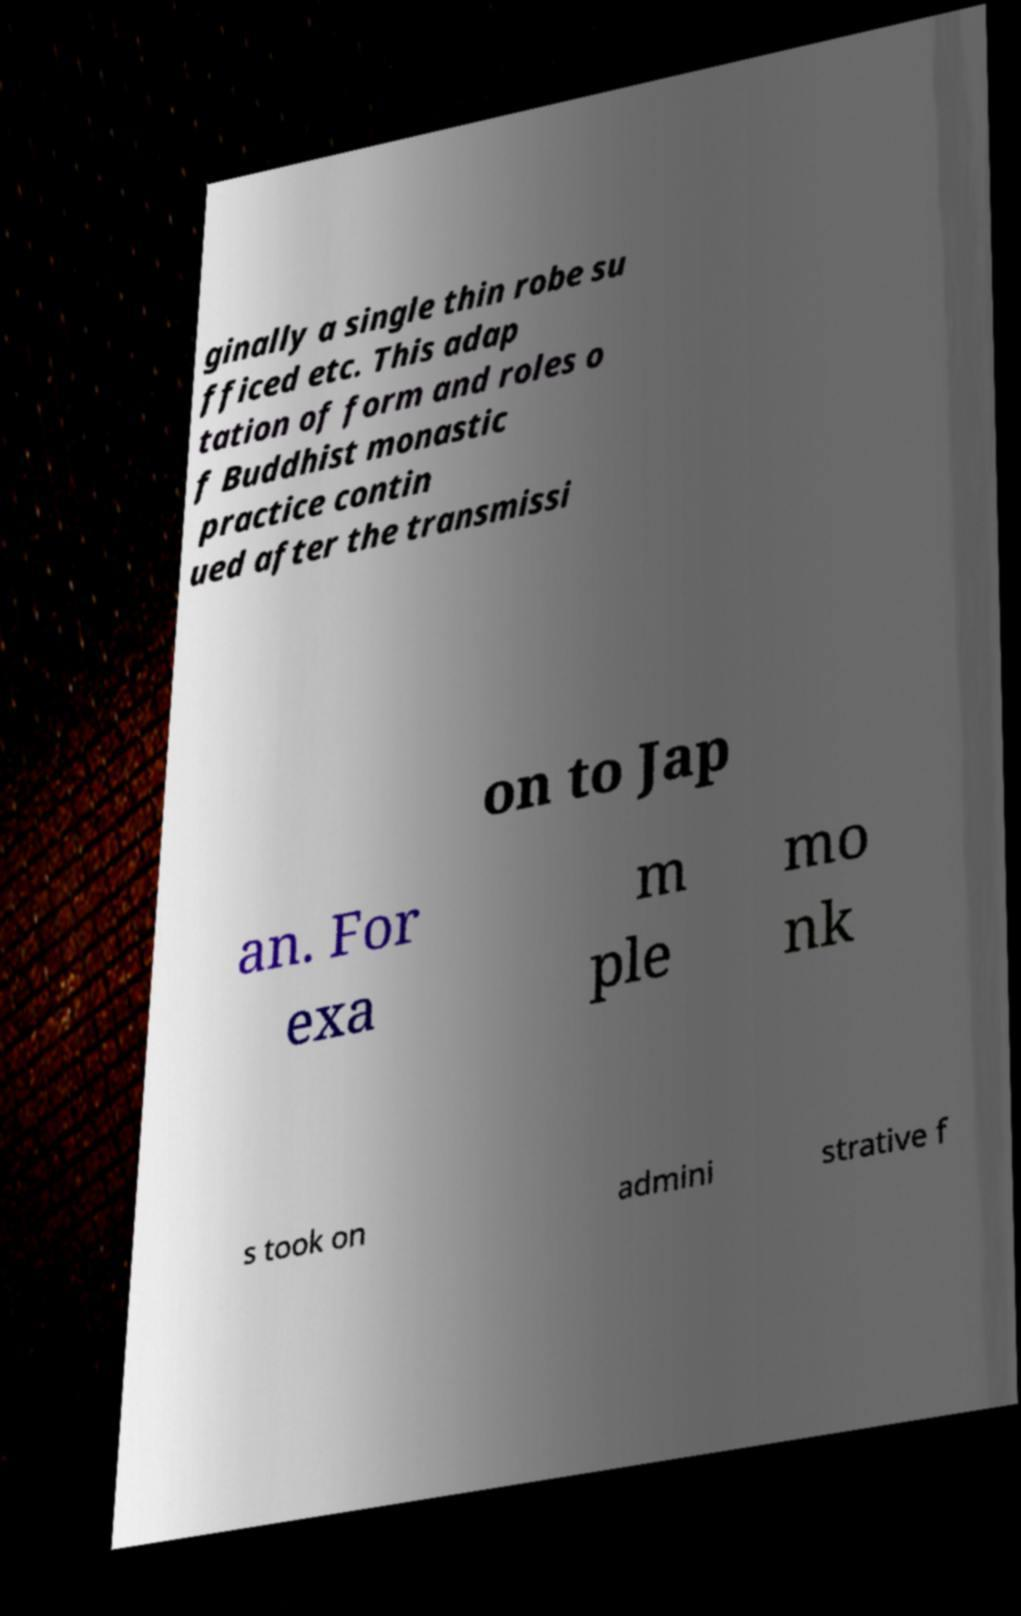I need the written content from this picture converted into text. Can you do that? ginally a single thin robe su fficed etc. This adap tation of form and roles o f Buddhist monastic practice contin ued after the transmissi on to Jap an. For exa m ple mo nk s took on admini strative f 